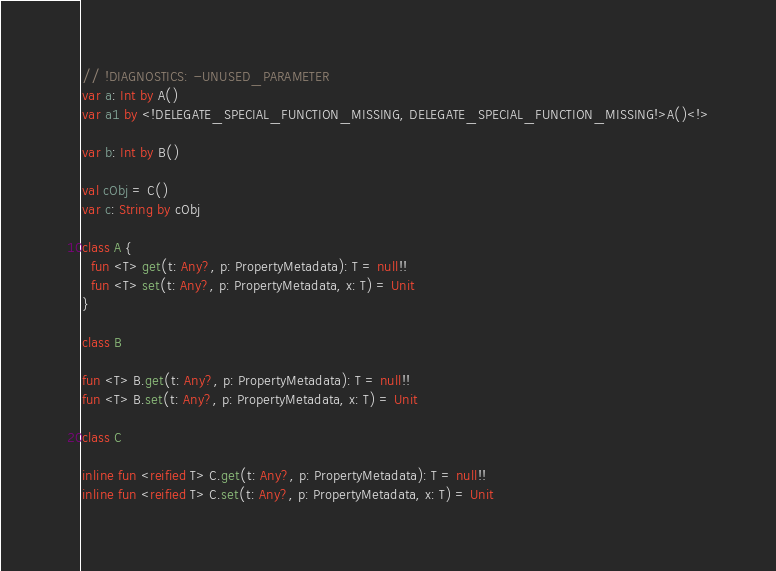Convert code to text. <code><loc_0><loc_0><loc_500><loc_500><_Kotlin_>// !DIAGNOSTICS: -UNUSED_PARAMETER
var a: Int by A()
var a1 by <!DELEGATE_SPECIAL_FUNCTION_MISSING, DELEGATE_SPECIAL_FUNCTION_MISSING!>A()<!>

var b: Int by B()

val cObj = C()
var c: String by cObj

class A {
  fun <T> get(t: Any?, p: PropertyMetadata): T = null!!
  fun <T> set(t: Any?, p: PropertyMetadata, x: T) = Unit
}

class B

fun <T> B.get(t: Any?, p: PropertyMetadata): T = null!!
fun <T> B.set(t: Any?, p: PropertyMetadata, x: T) = Unit

class C

inline fun <reified T> C.get(t: Any?, p: PropertyMetadata): T = null!!
inline fun <reified T> C.set(t: Any?, p: PropertyMetadata, x: T) = Unit
</code> 